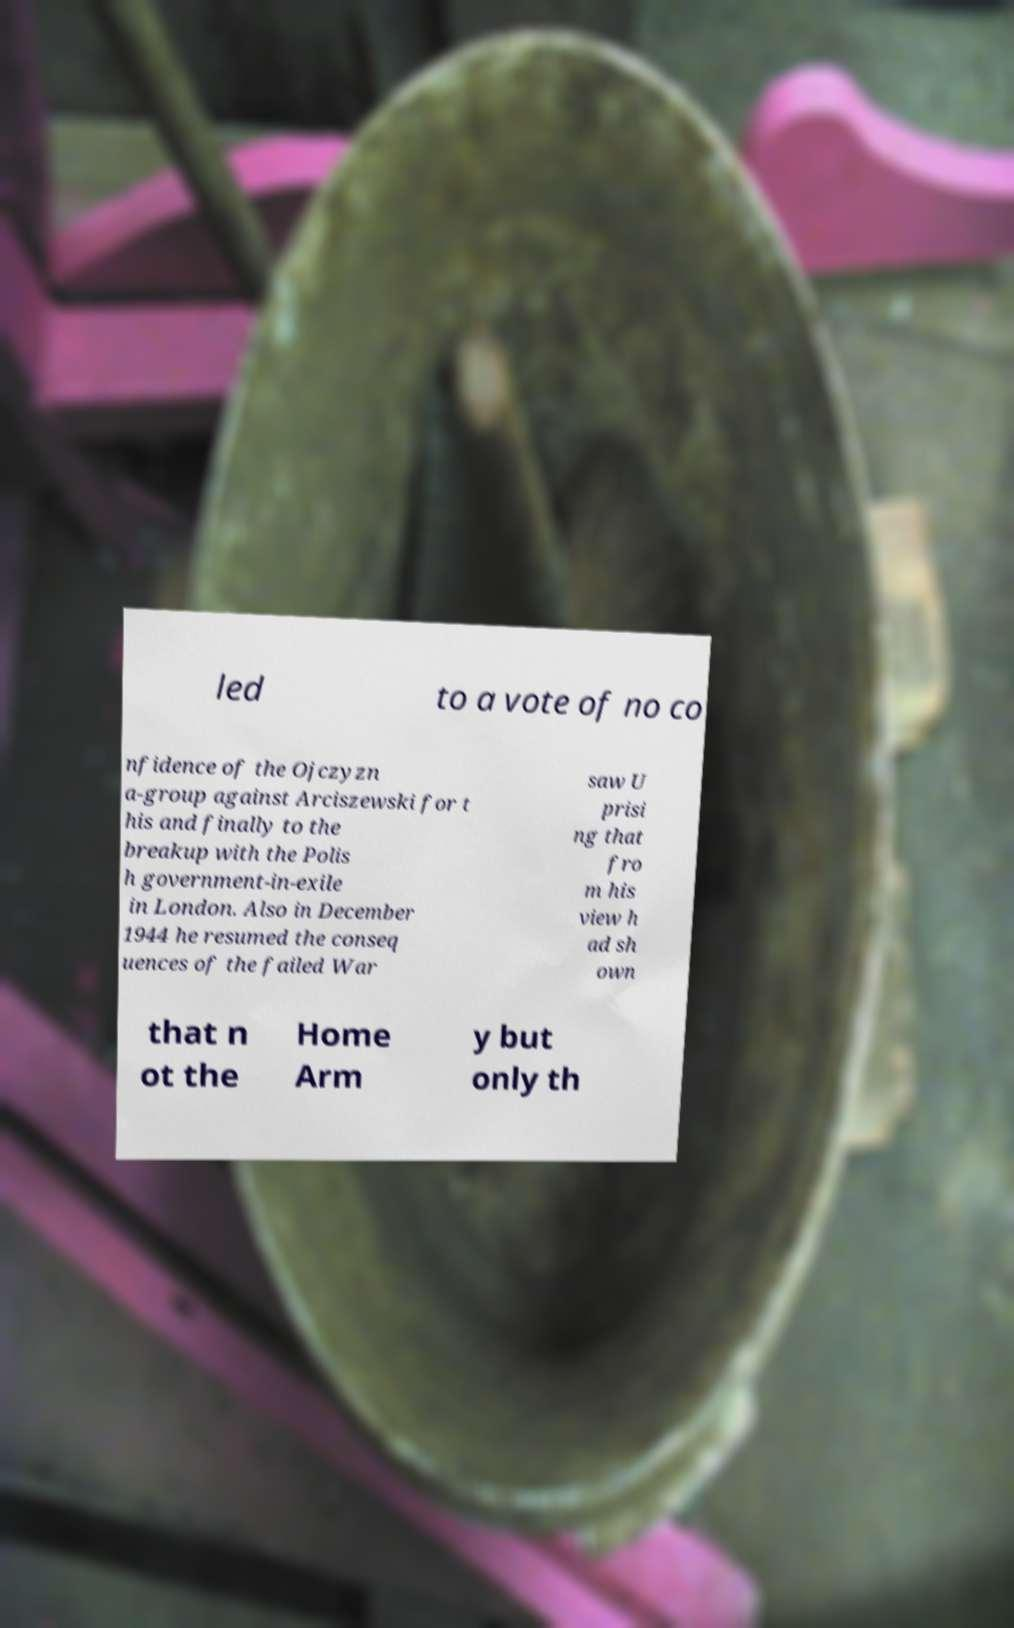Please identify and transcribe the text found in this image. led to a vote of no co nfidence of the Ojczyzn a-group against Arciszewski for t his and finally to the breakup with the Polis h government-in-exile in London. Also in December 1944 he resumed the conseq uences of the failed War saw U prisi ng that fro m his view h ad sh own that n ot the Home Arm y but only th 